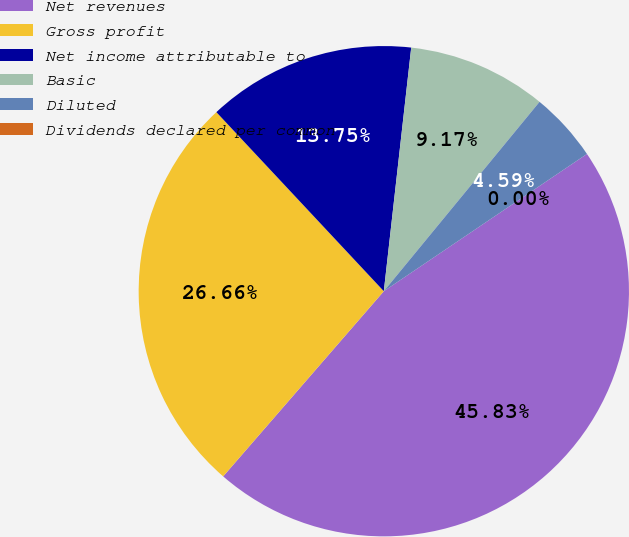Convert chart to OTSL. <chart><loc_0><loc_0><loc_500><loc_500><pie_chart><fcel>Net revenues<fcel>Gross profit<fcel>Net income attributable to<fcel>Basic<fcel>Diluted<fcel>Dividends declared per common<nl><fcel>45.83%<fcel>26.66%<fcel>13.75%<fcel>9.17%<fcel>4.59%<fcel>0.0%<nl></chart> 